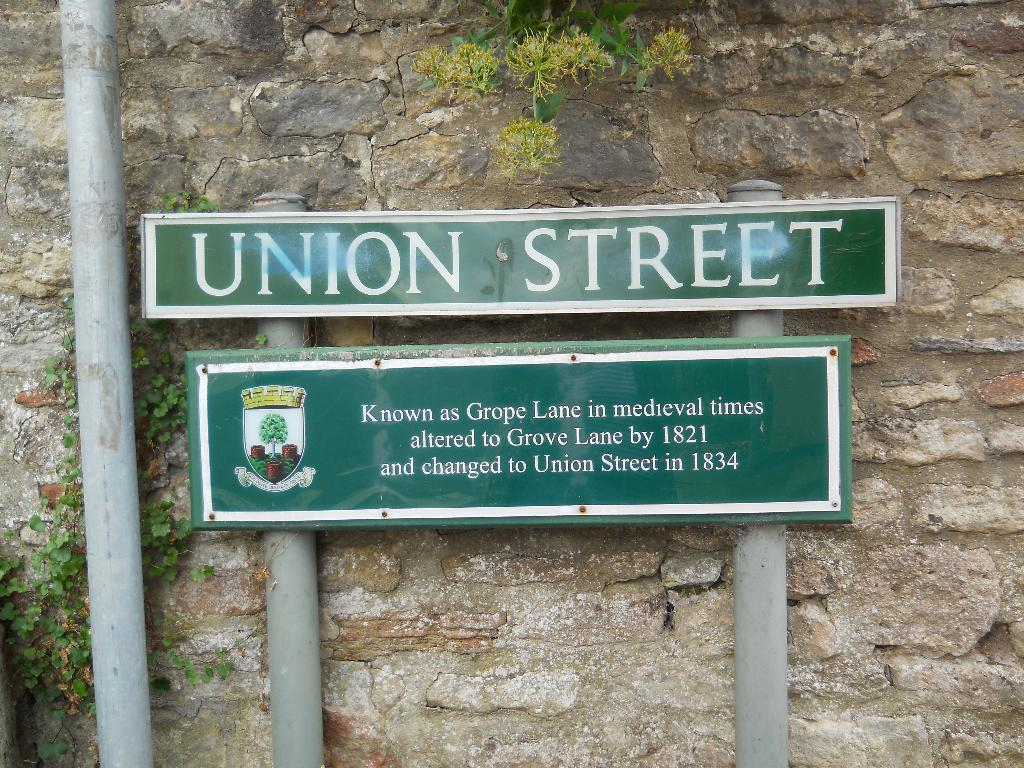What is located in the middle of the image? There is a hoarding or board in the middle of the image. What can be seen on the left side of the image? There is a board and plants on the left side of the image. What is visible in the background of the image? There is a tree and a wall in the background of the image. Can you see any dinosaurs in the image? No, there are no dinosaurs present in the image. Is there a spy hiding behind the board on the left side of the image? There is no indication of a spy in the image; it only features a board and plants on the left side. 